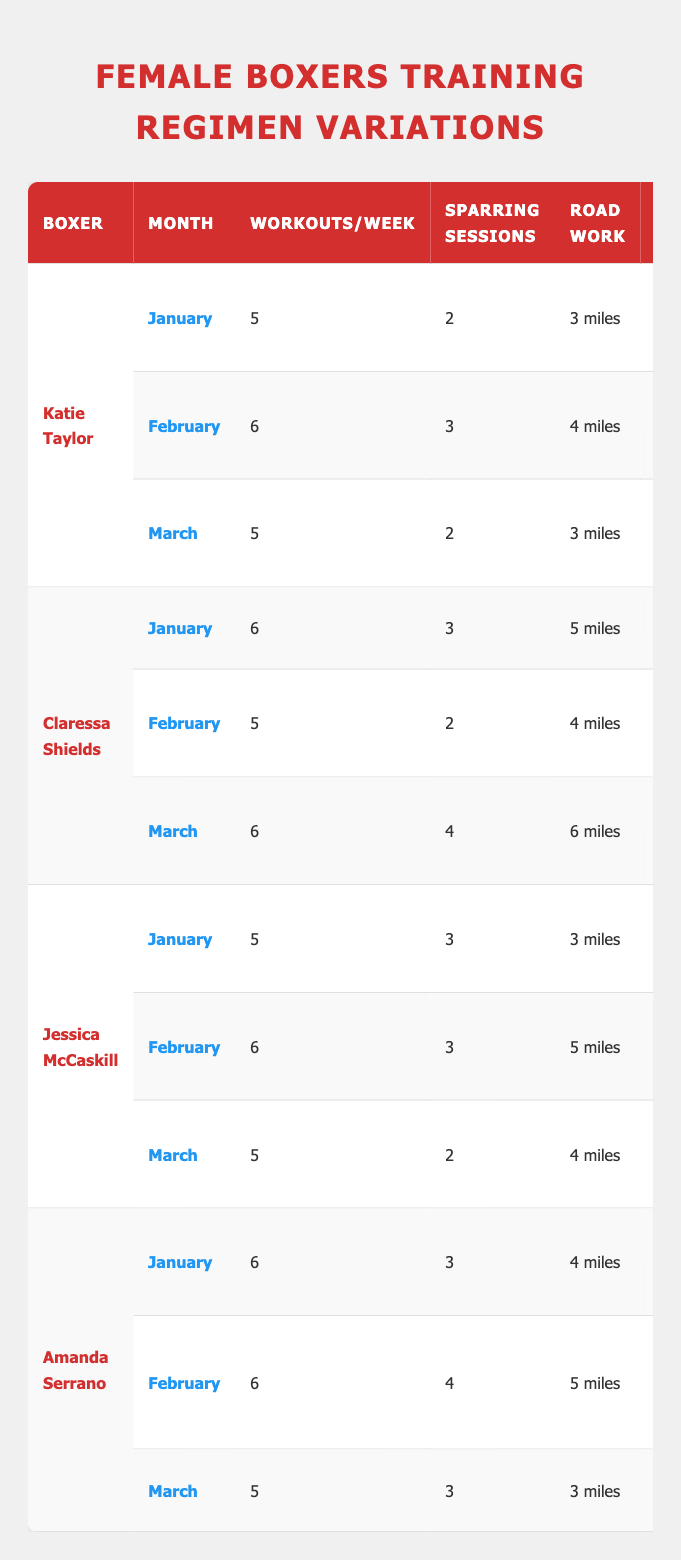What is the focus of Katie Taylor's training in February? The table shows that in February, Katie Taylor's focus is on "Power and Speed."
Answer: Power and Speed How many sparring sessions does Claressa Shields have in March? Referring to the table, Claressa Shields has 4 sparring sessions in March.
Answer: 4 Which boxer had the highest number of workouts per week in January? In January, Claressa Shields had the highest number of workouts per week with 6 sessions.
Answer: Claressa Shields What is the total number of strength training sessions for Jessica McCaskill across the season? Adding up her strength training sessions from January (3), February (4), and March (3) gives 3 + 4 + 3 = 10 sessions.
Answer: 10 How many miles does Amanda Serrano run in total during January and February? Amanda runs 4 miles in January and 5 miles in February, so the total is 4 + 5 = 9 miles.
Answer: 9 Does Jessica McCaskill do more workouts per week in February than in January? In January, Jessica had 5 workouts, and in February, she had 6 workouts. Since 6 > 5, the answer is yes.
Answer: Yes Which boxer focuses on "Sparring and Defense" in March? According to the table, Claressa Shields focuses on "Sparring and Defense" in March.
Answer: Claressa Shields What was the average number of workouts per week for Amanda Serrano during January and March? For January, it’s 6 workouts, and for March, it’s 5 workouts. The average is (6 + 5) / 2 = 5.5 workouts.
Answer: 5.5 How does the total number of road work miles for Katie Taylor compare from January to March? In January, she runs 3 miles and in March, she runs 3 miles. Since both values are equal, they are the same.
Answer: Same Which boxer has the least total strength training sessions in February? Each boxer's strength training sessions in February: Katie Taylor (2), Claressa Shields (3), Jessica McCaskill (4), Amanda Serrano (2). The least is Katie Taylor and Amanda Serrano with 2 sessions.
Answer: Katie Taylor and Amanda Serrano 